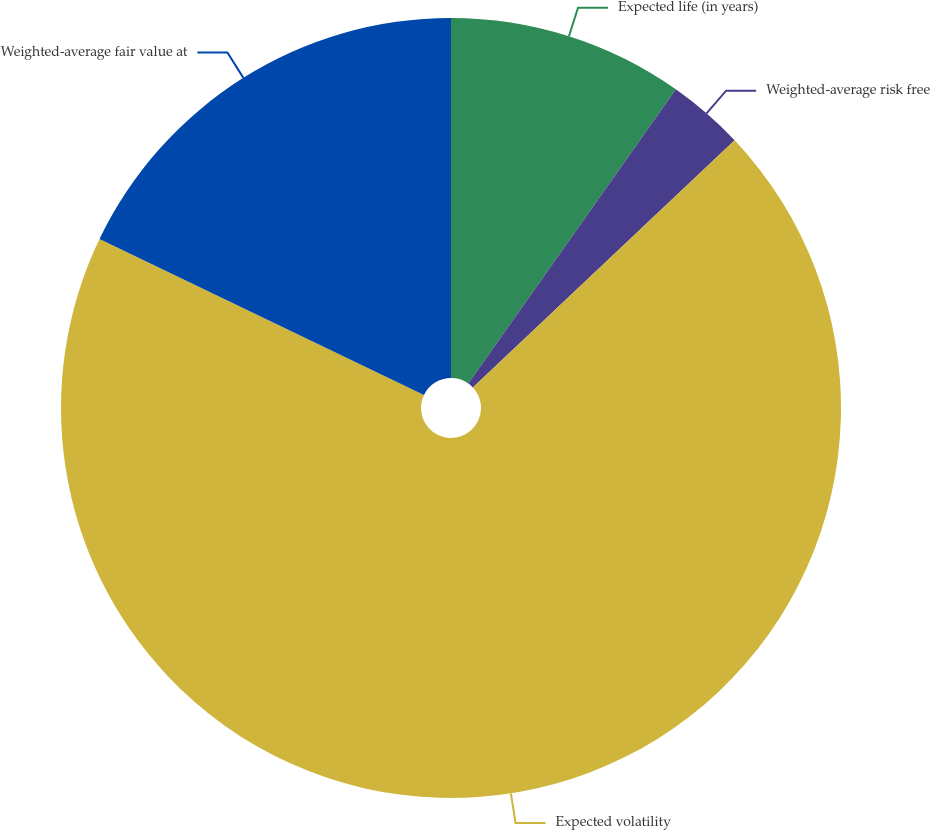Convert chart to OTSL. <chart><loc_0><loc_0><loc_500><loc_500><pie_chart><fcel>Expected life (in years)<fcel>Weighted-average risk free<fcel>Expected volatility<fcel>Weighted-average fair value at<nl><fcel>9.78%<fcel>3.18%<fcel>69.17%<fcel>17.87%<nl></chart> 